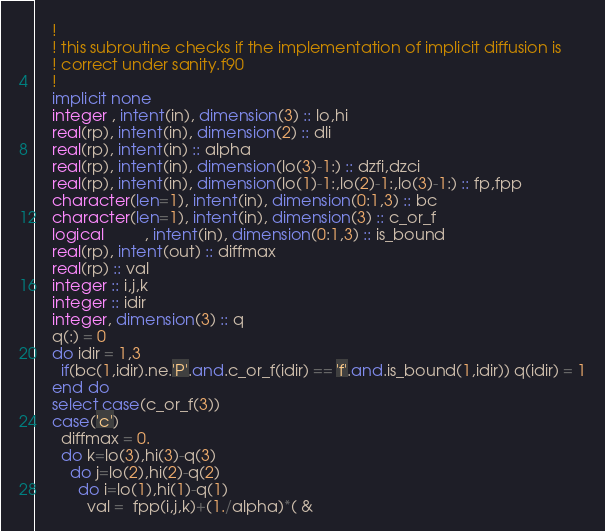Convert code to text. <code><loc_0><loc_0><loc_500><loc_500><_FORTRAN_>    !
    ! this subroutine checks if the implementation of implicit diffusion is
    ! correct under sanity.f90
    !
    implicit none
    integer , intent(in), dimension(3) :: lo,hi
    real(rp), intent(in), dimension(2) :: dli
    real(rp), intent(in) :: alpha
    real(rp), intent(in), dimension(lo(3)-1:) :: dzfi,dzci
    real(rp), intent(in), dimension(lo(1)-1:,lo(2)-1:,lo(3)-1:) :: fp,fpp
    character(len=1), intent(in), dimension(0:1,3) :: bc
    character(len=1), intent(in), dimension(3) :: c_or_f
    logical         , intent(in), dimension(0:1,3) :: is_bound
    real(rp), intent(out) :: diffmax
    real(rp) :: val
    integer :: i,j,k
    integer :: idir
    integer, dimension(3) :: q
    q(:) = 0
    do idir = 1,3
      if(bc(1,idir).ne.'P'.and.c_or_f(idir) == 'f'.and.is_bound(1,idir)) q(idir) = 1
    end do
    select case(c_or_f(3))
    case('c')
      diffmax = 0.
      do k=lo(3),hi(3)-q(3)
        do j=lo(2),hi(2)-q(2)
          do i=lo(1),hi(1)-q(1)
            val =  fpp(i,j,k)+(1./alpha)*( &</code> 